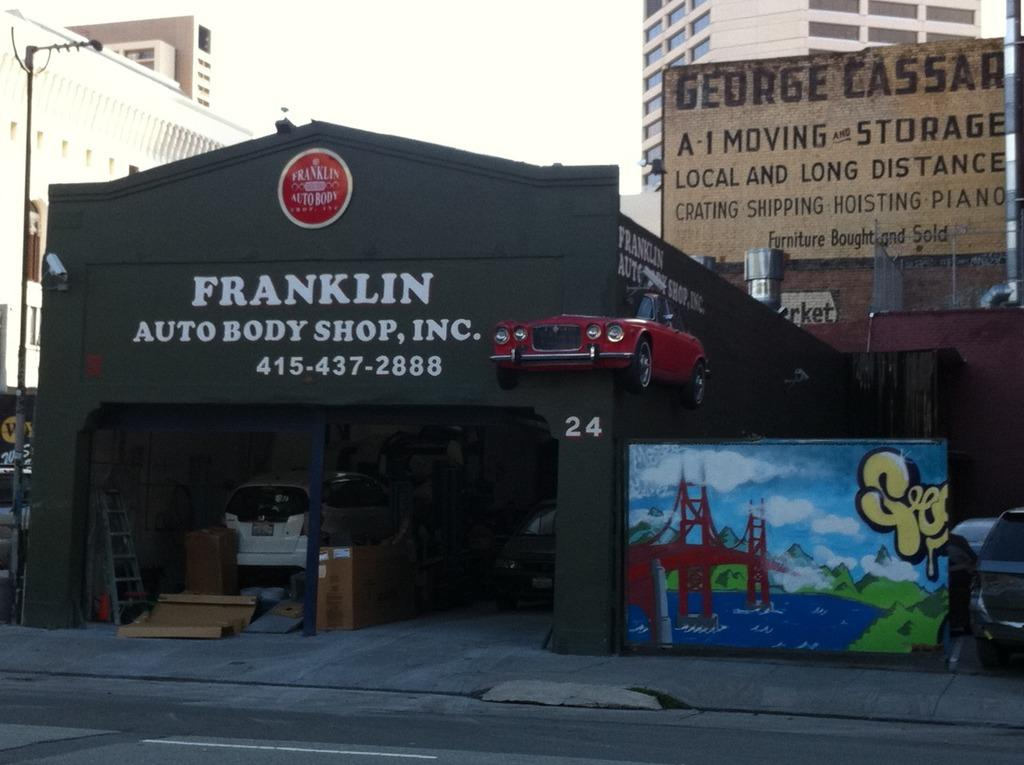<image>
Render a clear and concise summary of the photo. Franklin Autobody shop with a display of an old car coming through the wall. 